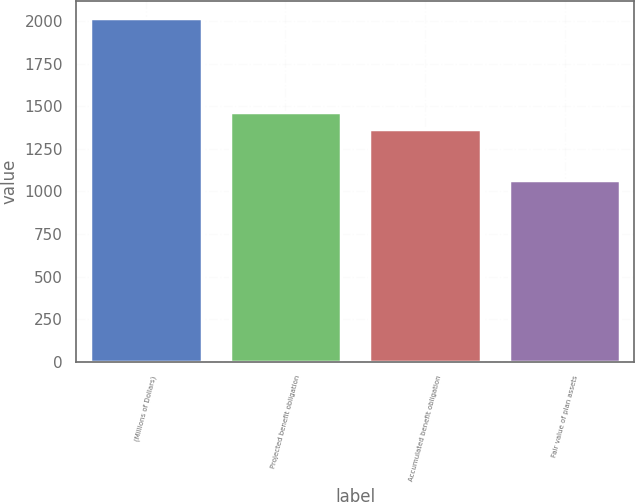Convert chart to OTSL. <chart><loc_0><loc_0><loc_500><loc_500><bar_chart><fcel>(Millions of Dollars)<fcel>Projected benefit obligation<fcel>Accumulated benefit obligation<fcel>Fair value of plan assets<nl><fcel>2017<fcel>1463.55<fcel>1368.7<fcel>1068.5<nl></chart> 